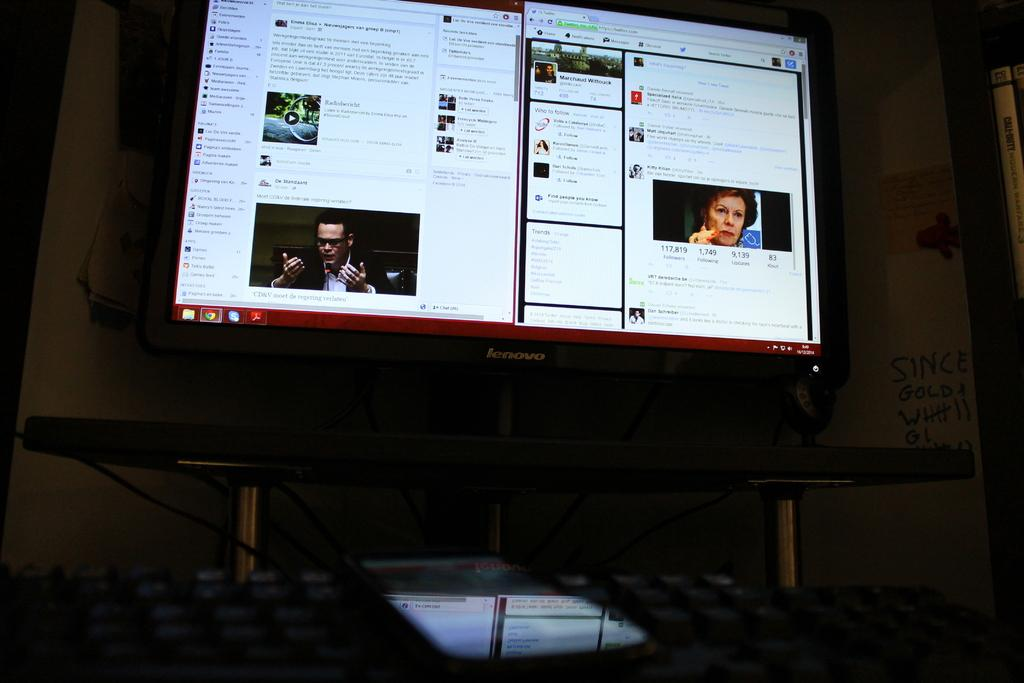Provide a one-sentence caption for the provided image. Lenovo computer monitor on a website for Marchaud Wittouck. 